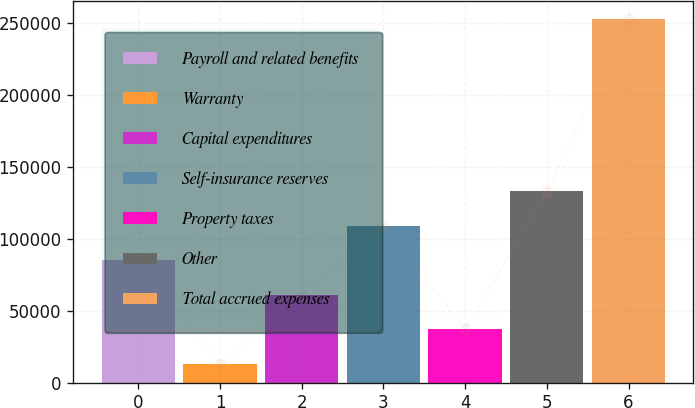<chart> <loc_0><loc_0><loc_500><loc_500><bar_chart><fcel>Payroll and related benefits<fcel>Warranty<fcel>Capital expenditures<fcel>Self-insurance reserves<fcel>Property taxes<fcel>Other<fcel>Total accrued expenses<nl><fcel>85040.8<fcel>13069<fcel>61050.2<fcel>109031<fcel>37059.6<fcel>133022<fcel>252975<nl></chart> 